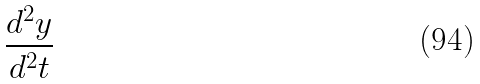<formula> <loc_0><loc_0><loc_500><loc_500>\frac { d ^ { 2 } y } { d ^ { 2 } t }</formula> 